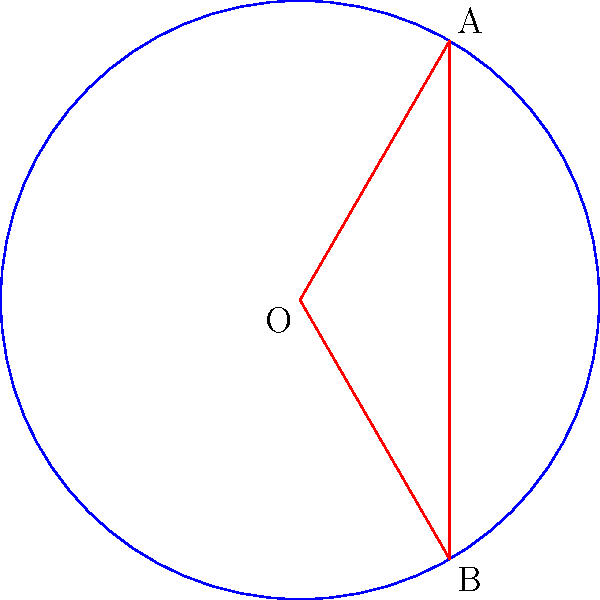A guitar pick-shaped segment is cut from a circular disc representing a vinyl record with a radius of 10 cm. If the central angle of this segment is 120°, calculate the area of the guitar pick-shaped segment. Round your answer to the nearest square centimeter. Let's approach this step-by-step:

1) The area of a circular segment is given by the formula:
   $$A = r^2 \left(\frac{\theta}{2} - \sin\frac{\theta}{2}\right)$$
   where $r$ is the radius and $\theta$ is the central angle in radians.

2) We're given:
   - Radius $r = 10$ cm
   - Central angle $\theta = 120°$

3) Convert the angle to radians:
   $$120° = 120 \cdot \frac{\pi}{180} = \frac{2\pi}{3} \approx 2.0944 \text{ radians}$$

4) Now, let's substitute these values into our formula:
   $$A = 10^2 \left(\frac{2\pi/3}{2} - \sin\frac{2\pi/3}{2}\right)$$

5) Simplify:
   $$A = 100 \left(\frac{\pi}{3} - \sin\frac{\pi}{3}\right)$$

6) We know that $\sin\frac{\pi}{3} = \frac{\sqrt{3}}{2}$, so:
   $$A = 100 \left(\frac{\pi}{3} - \frac{\sqrt{3}}{2}\right)$$

7) Calculate:
   $$A \approx 100 (1.0472 - 0.8660) \approx 18.12 \text{ cm}^2$$

8) Rounding to the nearest square centimeter:
   $$A \approx 18 \text{ cm}^2$$
Answer: 18 cm² 